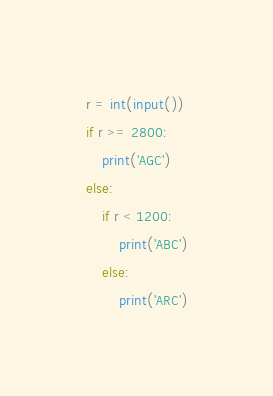Convert code to text. <code><loc_0><loc_0><loc_500><loc_500><_Python_>r = int(input())
if r >= 2800:
    print('AGC')
else:
    if r < 1200:
        print('ABC')
    else:
        print('ARC')</code> 